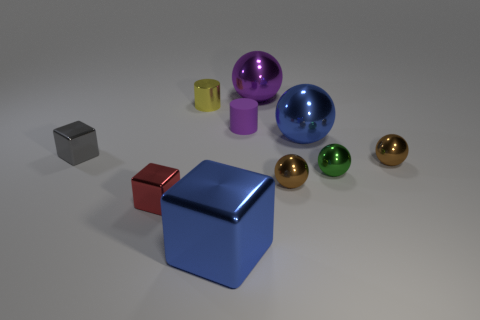Subtract 3 spheres. How many spheres are left? 2 Subtract all small green metal spheres. How many spheres are left? 4 Subtract all red cylinders. How many brown spheres are left? 2 Subtract all blue balls. How many balls are left? 4 Subtract all cyan balls. Subtract all blue cylinders. How many balls are left? 5 Subtract all cubes. How many objects are left? 7 Subtract all cyan matte objects. Subtract all large blue metallic things. How many objects are left? 8 Add 3 small red metal cubes. How many small red metal cubes are left? 4 Add 4 gray cubes. How many gray cubes exist? 5 Subtract 0 green blocks. How many objects are left? 10 